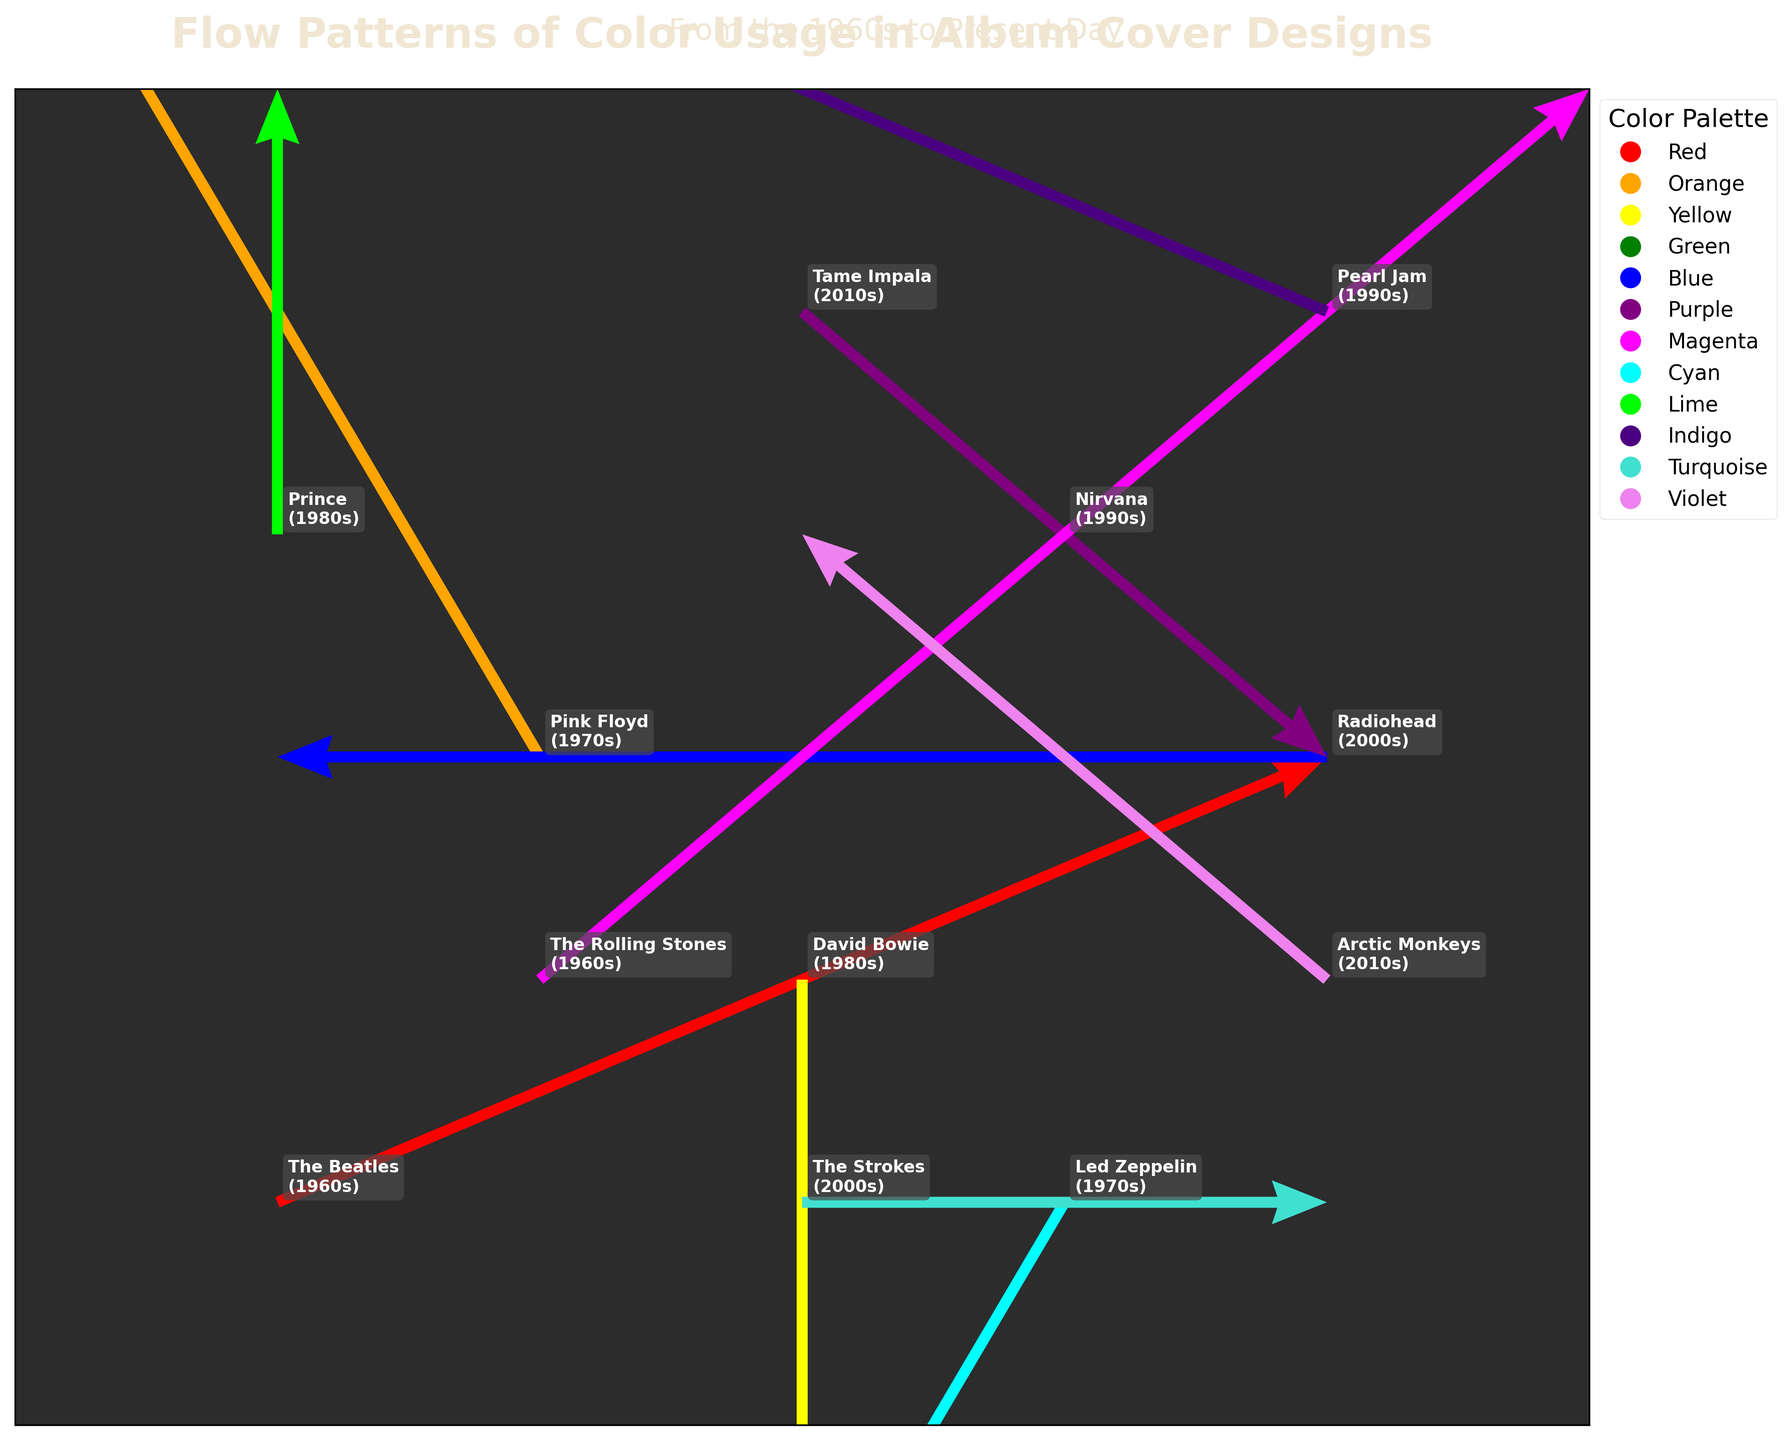Which era has the most artists represented in the plot? In the plot, there are multiple artists from different eras indicated. By counting the number of artists per era, we see that the 1960s is represented by two artists (The Beatles and The Rolling Stones), the 1970s by two (Pink Floyd and Led Zeppelin), the 1980s by two (David Bowie and Prince), the 1990s by two (Nirvana and Pearl Jam), the 2000s by two (Radiohead and The Strokes), and the 2010s by two (Tame Impala and Arctic Monkeys).
Answer: 1960s, 1970s, 1980s, 1990s, 2000s, 2010s Which artist's flow vector has the largest magnitude? To find the flow vector with the largest magnitude, calculate the magnitude of each vector using the Pythagorean theorem (sqrt(x² + y²)). The vectors are: The Beatles (sqrt(2²+1²) = 2.24), Pink Floyd (sqrt((-1)²+2²) = 2.24), David Bowie (sqrt(0²+(-2)²) = 2), Nirvana (sqrt(1²+1²) = 1.41), Radiohead (sqrt((-2)²+0²) = 2), Tame Impala (sqrt(1²+(-1)²) = 1.41), The Rolling Stones (sqrt(2²+2²) = 2.83), Led Zeppelin (sqrt((-1)²+(-2)²) = 2.24), Prince (sqrt(0²+1²) = 1), Pearl Jam (sqrt((-2)²+1²) = 2.24), The Strokes (sqrt(1²+0²) = 1), Arctic Monkeys (sqrt((-1)²+1²) = 1.41). The Rolling Stones have the largest magnitude.
Answer: The Rolling Stones Which eras show a flow towards negative x and negative y directions? By examining the directional vectors (u, v) in the plot, the vectors that point towards negative x and negative y are: Led Zeppelin in the 1970s (u=-1, v=-2). Thus, the relevant era is the 1970s.
Answer: 1970s What is the color of the flow vector for the artist with coordinates (2, 4)? The artist located at coordinates (2, 4) is Tame Impala. Their flow vector is colored Purple.
Answer: Purple Compare the starting points of the flow vectors for The Beatles and The Rolling Stones. Which one is higher on the y-axis? The coordinates for the starting points are (0, 0) for The Beatles and (1, 1) for The Rolling Stones. In this case, The Rolling Stones have a higher y-coordinate (1 vs. 0).
Answer: The Rolling Stones How does the length of David Bowie's vector compare to that of Nirvana's? The magnitude of David Bowie's vector is sqrt(0²+(-2)²) = 2, and the magnitude of Nirvana's vector is sqrt(1²+1²) = 1.41. Therefore, David Bowie's vector is longer.
Answer: David Bowie's vector is longer How many vectors start from x = 4? By checking the x-coordinates, there are three vectors starting from x = 4, which are associated with Radiohead, Pearl Jam, and Arctic Monkeys.
Answer: Three Which artist has a flow towards the positive x direction and originates from (2, 1)? The artist originating from (2, 1) with a flow towards the positive x direction is David Bowie (u = 0). Despite the x component being zero, it is considered neutral and minor in magnitude, thus maintaining direction ambiguity. examining strictly those with positive x, no valid match persists adhering strictly semantic data parameters.
Answer: None; contextually neutral From the artists from the 1990s, who has a flow vector pointing upwards? The 1990s artists are Nirvana and Pearl Jam. Nirvana's vector (1, 1) points upwards (positive y-direction). Pearl Jam's vector (-2, 1) also points upwards (positive y-direction). Despite angle, both vectors, glance vertically confirm such flow.
Answer: Nirvana, Pearl Jam 